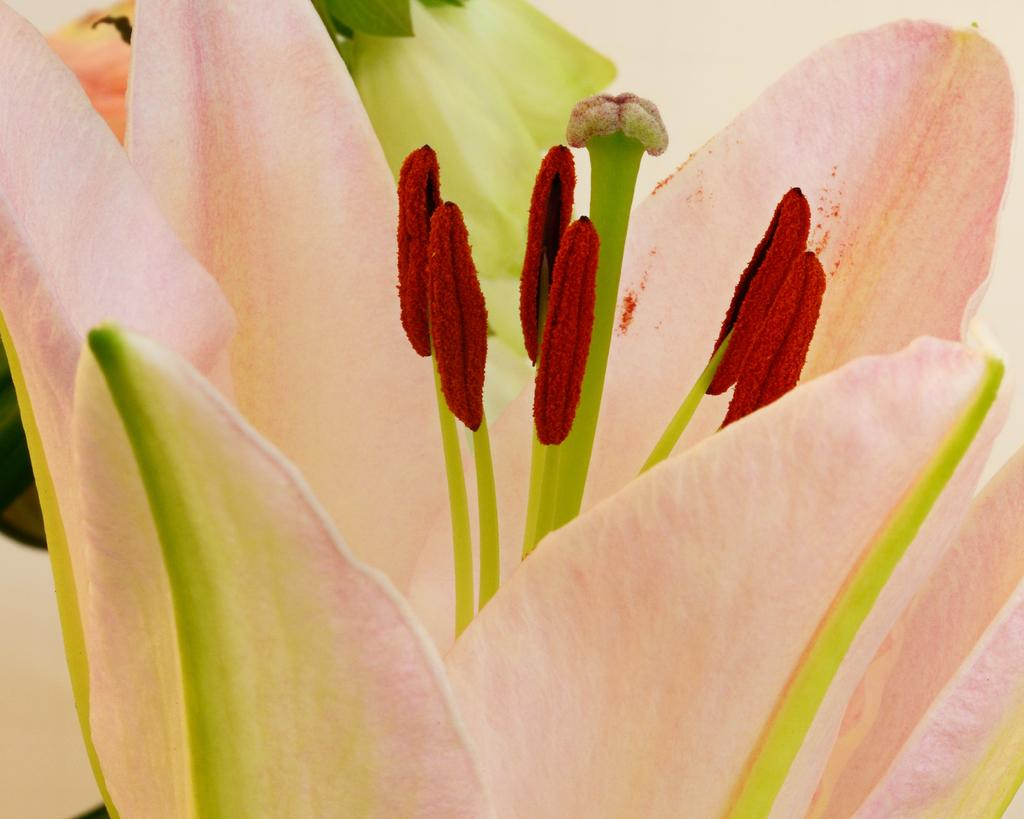What is the main subject of the image? There is a flower in the image. Can you describe any specific features of the flower? The flower appears to have a leaf. What else can be seen in the background of the image? There are additional flowers in the background of the image. How many pizzas are being held by the flower in the image? There are no pizzas present in the image; it features a flower with a leaf and additional flowers in the background. What type of muscle can be seen in the image? There is no muscle visible in the image; it features a flower with a leaf and additional flowers in the background. 